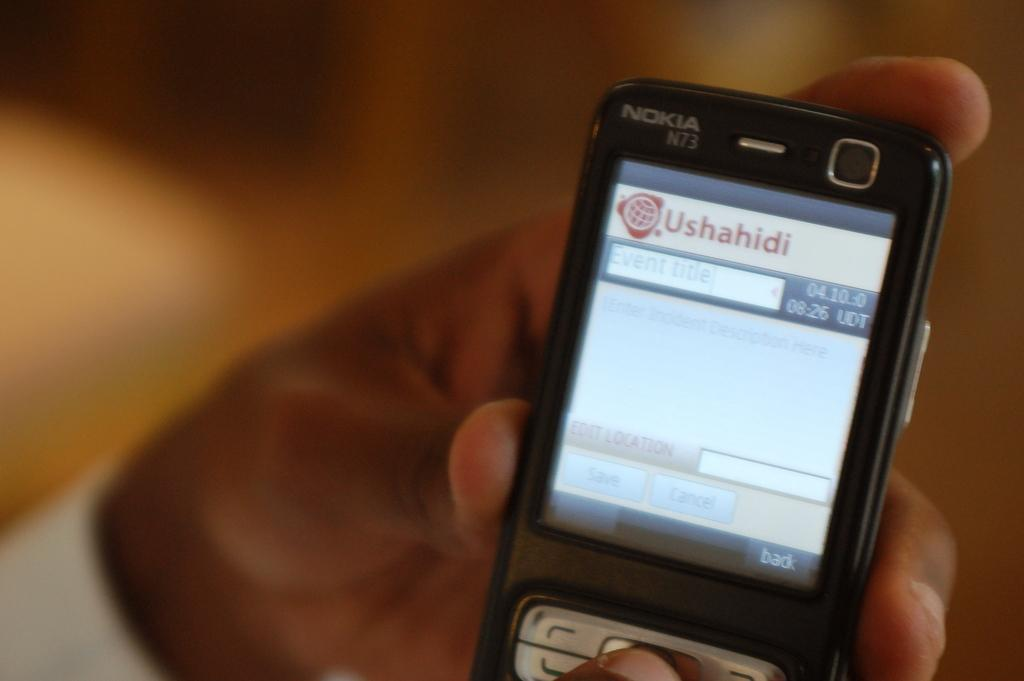<image>
Describe the image concisely. A man holding a phone opened to the Ushahidi app. 